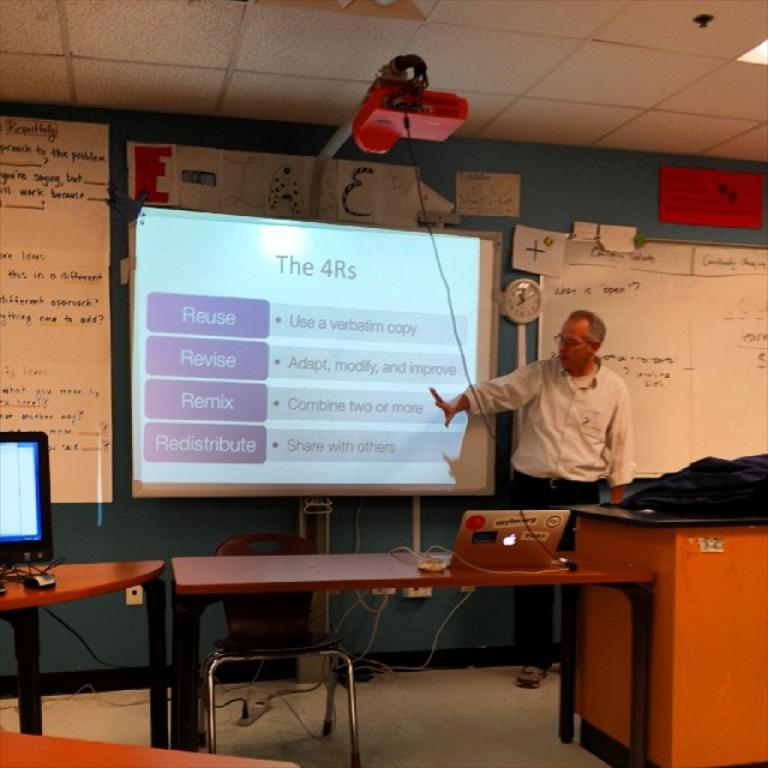What is the main subject of the image? There is a man standing in the image. Where is the man standing? The man is standing on the floor. What furniture can be seen in the image? There is a table and a chair in the image. What electronic device is on the table? A laptop is present on the table. What is hanging on the wall in the image? There is a board in the image. What part of the room is visible in the image? The roof is visible in the image. What type of stocking is hanging from the ceiling in the image? There is no stocking hanging from the ceiling in the image. What appliance is being used by the man in the image? The image does not show the man using any appliance. 